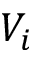<formula> <loc_0><loc_0><loc_500><loc_500>V _ { i }</formula> 